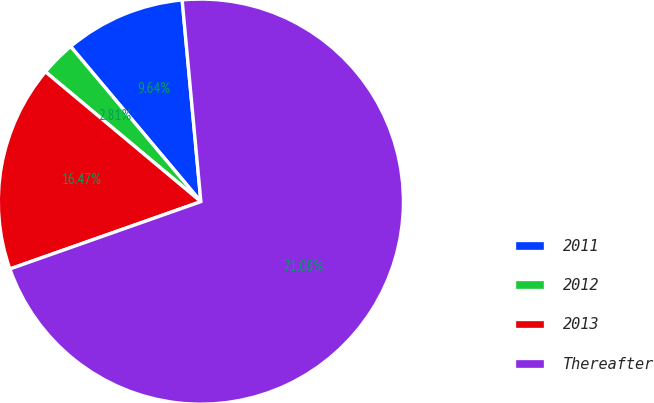Convert chart. <chart><loc_0><loc_0><loc_500><loc_500><pie_chart><fcel>2011<fcel>2012<fcel>2013<fcel>Thereafter<nl><fcel>9.64%<fcel>2.81%<fcel>16.47%<fcel>71.08%<nl></chart> 